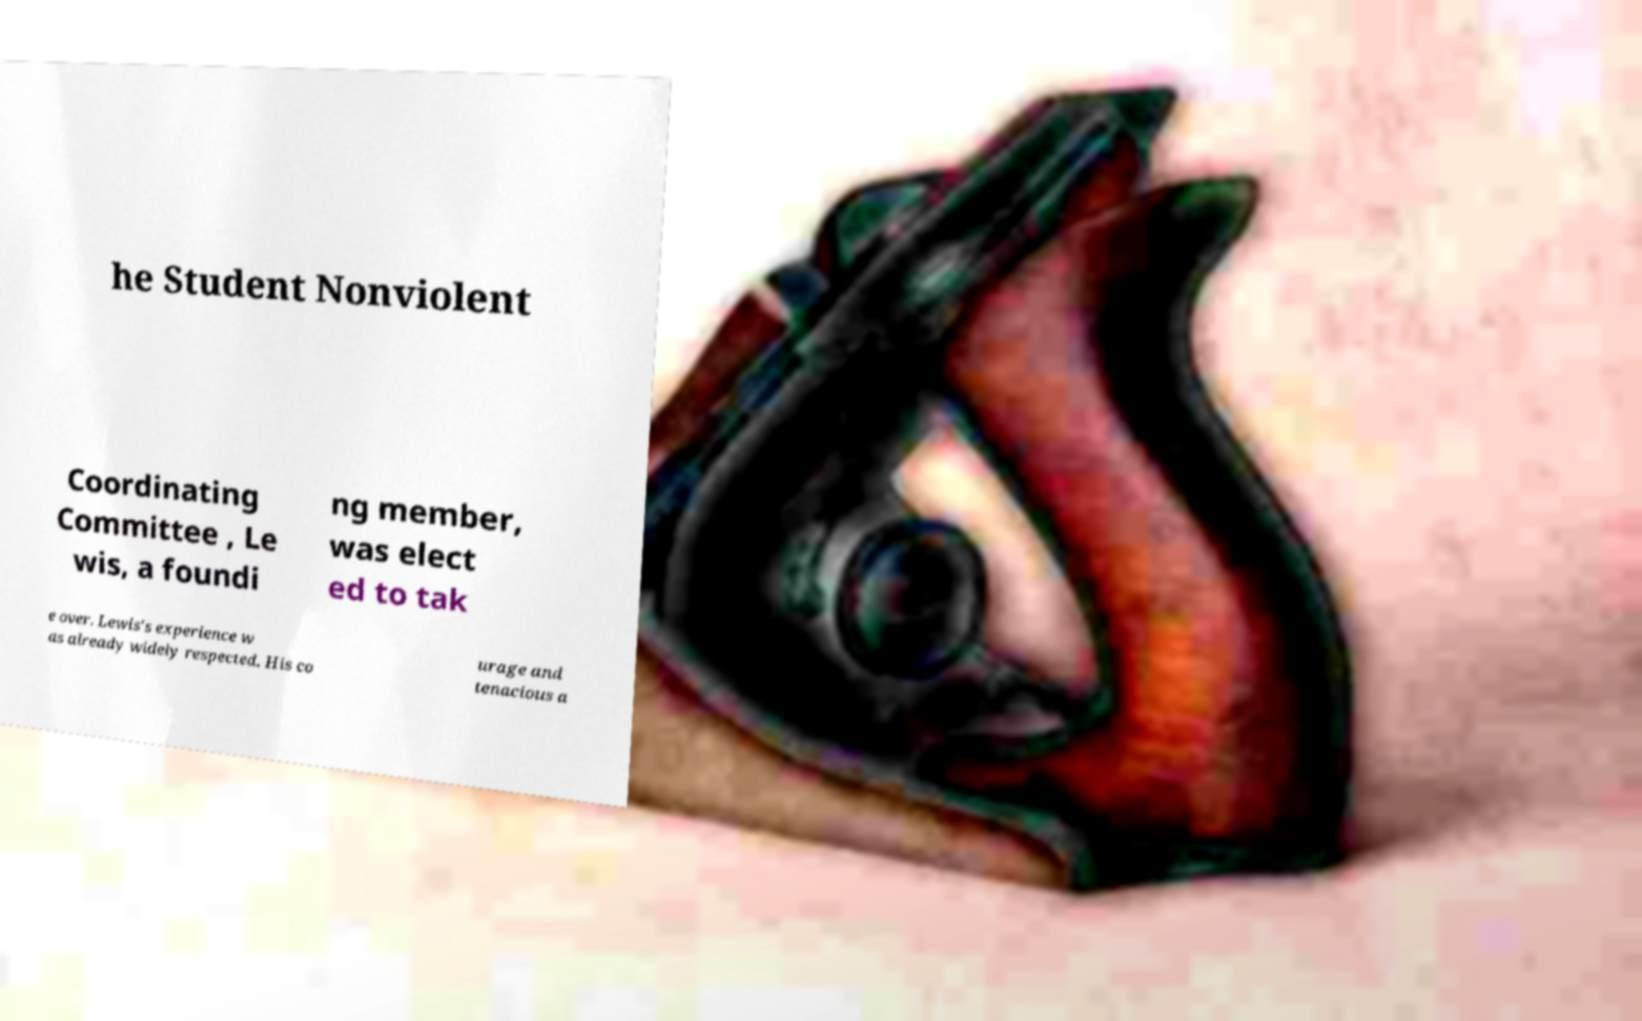Can you read and provide the text displayed in the image?This photo seems to have some interesting text. Can you extract and type it out for me? he Student Nonviolent Coordinating Committee , Le wis, a foundi ng member, was elect ed to tak e over. Lewis's experience w as already widely respected. His co urage and tenacious a 